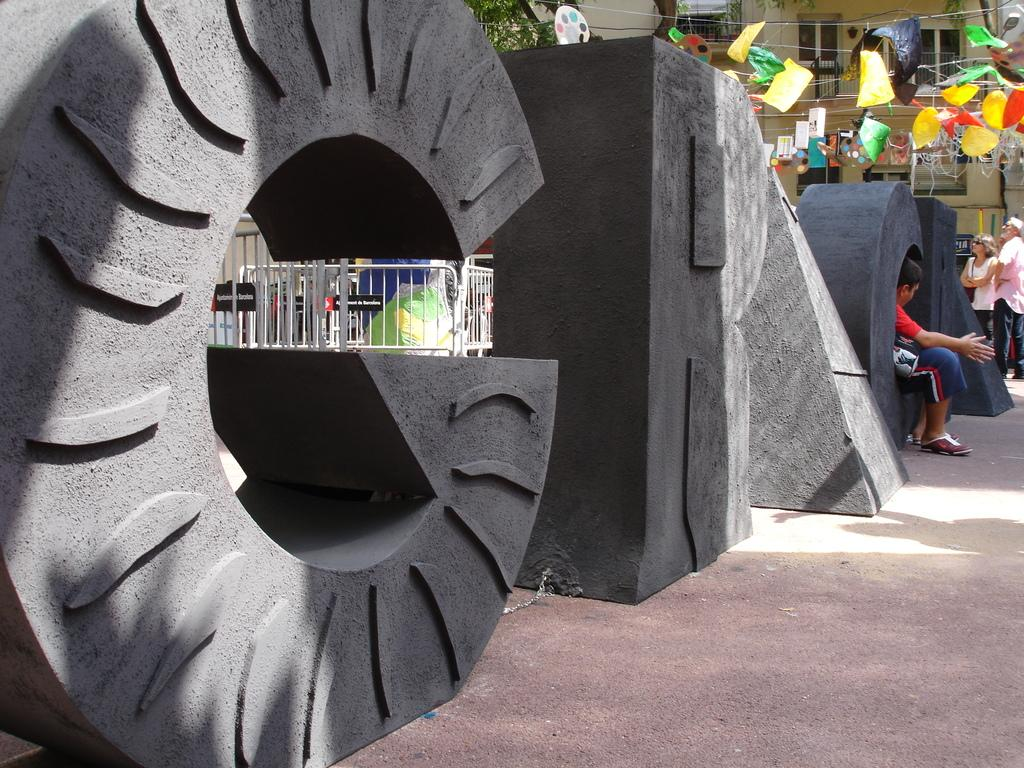What type of structures can be seen in the image? There are buildings in the image. What natural element is present in the image? There is a tree in the image. Are there any human figures in the image? Yes, there are people standing in the image. What type of decorative items can be seen in the image? There are color papers in the image. What type of barrier is present in the image? There is a metal fence in the image. What type of artistic feature can be seen on the sidewalk in the image? There are alphabets made with concrete on the sidewalk in the image. What type of account is being discussed in the image? There is no mention of an account in the image; it features buildings, a tree, people, color papers, a metal fence, and alphabets made with concrete on the sidewalk. Can you see any clouds in the image? There is no mention of clouds in the image; it only features buildings, a tree, people, color papers, a metal fence, and alphabets made with concrete on the sidewalk. 